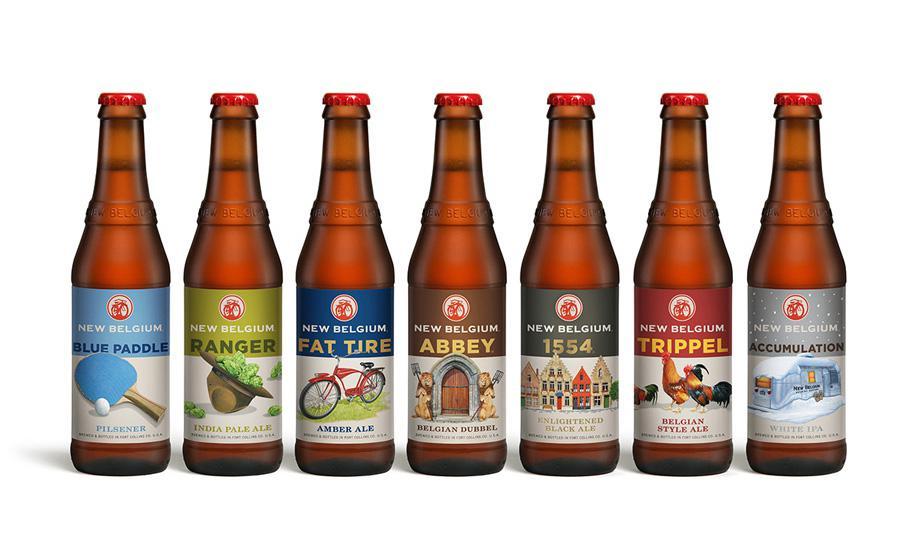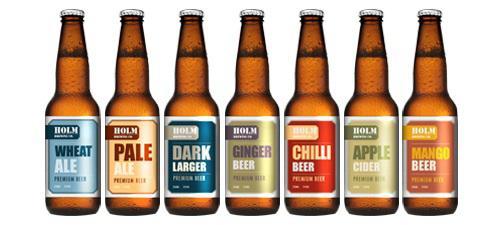The first image is the image on the left, the second image is the image on the right. Analyze the images presented: Is the assertion "One image contains only two containers of beer." valid? Answer yes or no. No. The first image is the image on the left, the second image is the image on the right. Given the left and right images, does the statement "One of the images shows a glass next to a bottle of beer and the other image shows a row of beer bottles." hold true? Answer yes or no. No. 